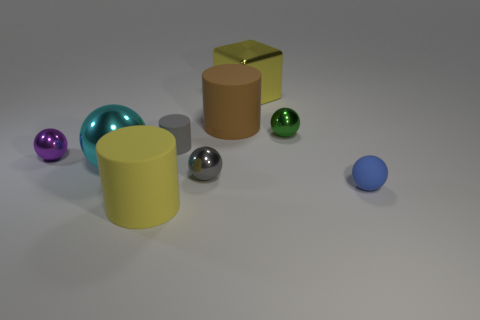Subtract all blue spheres. How many spheres are left? 4 Subtract all large cyan balls. How many balls are left? 4 Subtract all yellow balls. Subtract all purple blocks. How many balls are left? 5 Add 1 tiny blue metallic blocks. How many objects exist? 10 Subtract all cylinders. How many objects are left? 6 Add 3 large yellow metallic things. How many large yellow metallic things exist? 4 Subtract 0 brown spheres. How many objects are left? 9 Subtract all gray metallic things. Subtract all big yellow cylinders. How many objects are left? 7 Add 7 big yellow matte objects. How many big yellow matte objects are left? 8 